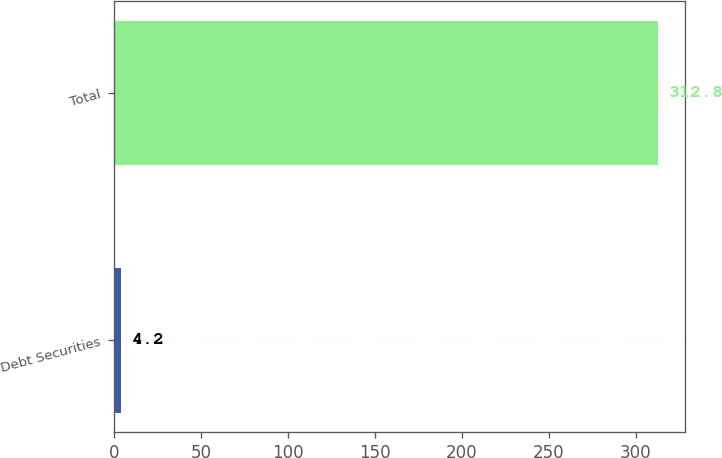Convert chart to OTSL. <chart><loc_0><loc_0><loc_500><loc_500><bar_chart><fcel>Debt Securities<fcel>Total<nl><fcel>4.2<fcel>312.8<nl></chart> 